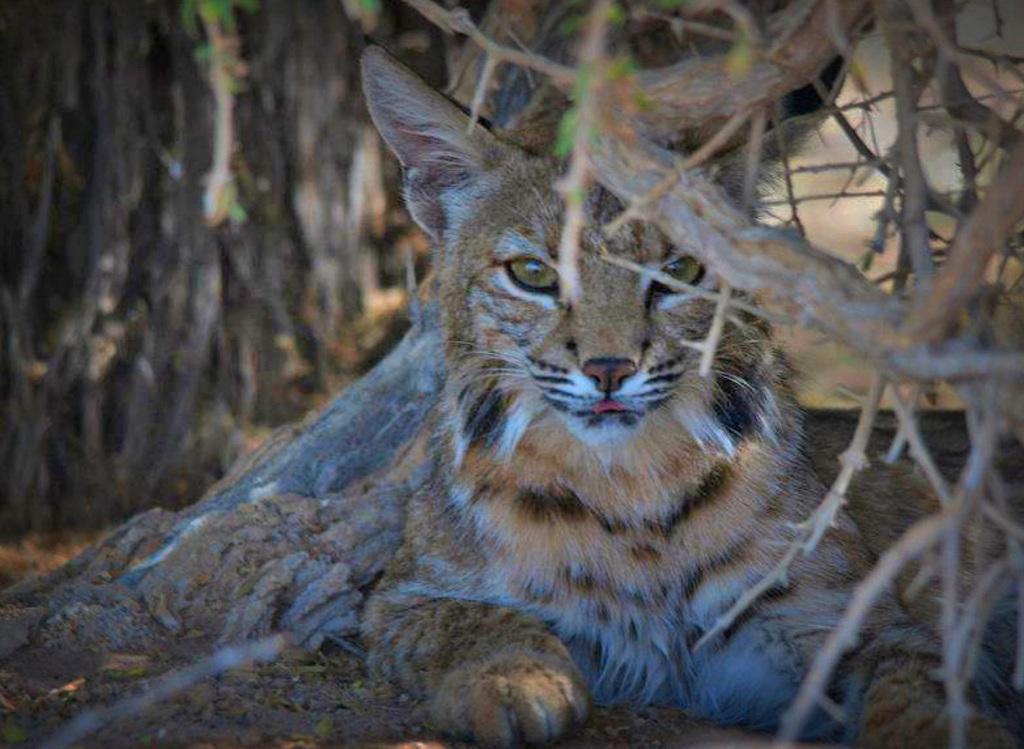How would you summarize this image in a sentence or two? In this image we can see bobcat. Also there are stems. In the background it is blur. 